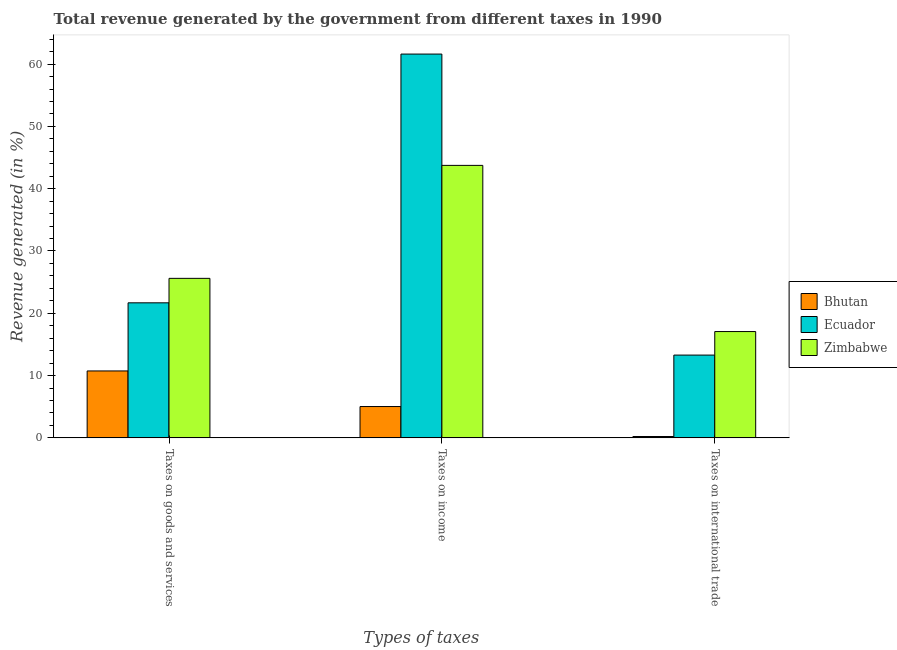Are the number of bars per tick equal to the number of legend labels?
Give a very brief answer. Yes. How many bars are there on the 1st tick from the left?
Provide a succinct answer. 3. What is the label of the 1st group of bars from the left?
Your response must be concise. Taxes on goods and services. What is the percentage of revenue generated by tax on international trade in Bhutan?
Make the answer very short. 0.22. Across all countries, what is the maximum percentage of revenue generated by taxes on income?
Your response must be concise. 61.61. Across all countries, what is the minimum percentage of revenue generated by taxes on goods and services?
Offer a terse response. 10.74. In which country was the percentage of revenue generated by tax on international trade maximum?
Give a very brief answer. Zimbabwe. In which country was the percentage of revenue generated by taxes on goods and services minimum?
Provide a succinct answer. Bhutan. What is the total percentage of revenue generated by taxes on income in the graph?
Give a very brief answer. 110.38. What is the difference between the percentage of revenue generated by taxes on goods and services in Zimbabwe and that in Ecuador?
Your answer should be compact. 3.93. What is the difference between the percentage of revenue generated by taxes on income in Bhutan and the percentage of revenue generated by tax on international trade in Zimbabwe?
Offer a very short reply. -12.04. What is the average percentage of revenue generated by taxes on income per country?
Provide a succinct answer. 36.79. What is the difference between the percentage of revenue generated by taxes on income and percentage of revenue generated by taxes on goods and services in Zimbabwe?
Offer a very short reply. 18.13. What is the ratio of the percentage of revenue generated by taxes on goods and services in Zimbabwe to that in Ecuador?
Provide a succinct answer. 1.18. Is the percentage of revenue generated by tax on international trade in Ecuador less than that in Bhutan?
Offer a terse response. No. Is the difference between the percentage of revenue generated by taxes on goods and services in Zimbabwe and Bhutan greater than the difference between the percentage of revenue generated by taxes on income in Zimbabwe and Bhutan?
Make the answer very short. No. What is the difference between the highest and the second highest percentage of revenue generated by taxes on income?
Your answer should be very brief. 17.87. What is the difference between the highest and the lowest percentage of revenue generated by tax on international trade?
Provide a succinct answer. 16.85. Is the sum of the percentage of revenue generated by taxes on income in Zimbabwe and Bhutan greater than the maximum percentage of revenue generated by tax on international trade across all countries?
Keep it short and to the point. Yes. What does the 3rd bar from the left in Taxes on goods and services represents?
Provide a short and direct response. Zimbabwe. What does the 3rd bar from the right in Taxes on international trade represents?
Make the answer very short. Bhutan. How many bars are there?
Provide a short and direct response. 9. Are all the bars in the graph horizontal?
Your response must be concise. No. What is the difference between two consecutive major ticks on the Y-axis?
Your answer should be very brief. 10. Are the values on the major ticks of Y-axis written in scientific E-notation?
Ensure brevity in your answer.  No. Does the graph contain any zero values?
Provide a succinct answer. No. Where does the legend appear in the graph?
Your answer should be very brief. Center right. How many legend labels are there?
Your answer should be very brief. 3. How are the legend labels stacked?
Your response must be concise. Vertical. What is the title of the graph?
Give a very brief answer. Total revenue generated by the government from different taxes in 1990. What is the label or title of the X-axis?
Make the answer very short. Types of taxes. What is the label or title of the Y-axis?
Give a very brief answer. Revenue generated (in %). What is the Revenue generated (in %) of Bhutan in Taxes on goods and services?
Give a very brief answer. 10.74. What is the Revenue generated (in %) in Ecuador in Taxes on goods and services?
Offer a terse response. 21.68. What is the Revenue generated (in %) of Zimbabwe in Taxes on goods and services?
Make the answer very short. 25.61. What is the Revenue generated (in %) in Bhutan in Taxes on income?
Make the answer very short. 5.03. What is the Revenue generated (in %) of Ecuador in Taxes on income?
Your answer should be compact. 61.61. What is the Revenue generated (in %) of Zimbabwe in Taxes on income?
Your response must be concise. 43.74. What is the Revenue generated (in %) in Bhutan in Taxes on international trade?
Offer a very short reply. 0.22. What is the Revenue generated (in %) of Ecuador in Taxes on international trade?
Keep it short and to the point. 13.29. What is the Revenue generated (in %) of Zimbabwe in Taxes on international trade?
Your answer should be very brief. 17.07. Across all Types of taxes, what is the maximum Revenue generated (in %) in Bhutan?
Provide a short and direct response. 10.74. Across all Types of taxes, what is the maximum Revenue generated (in %) of Ecuador?
Keep it short and to the point. 61.61. Across all Types of taxes, what is the maximum Revenue generated (in %) of Zimbabwe?
Your answer should be very brief. 43.74. Across all Types of taxes, what is the minimum Revenue generated (in %) in Bhutan?
Your response must be concise. 0.22. Across all Types of taxes, what is the minimum Revenue generated (in %) in Ecuador?
Make the answer very short. 13.29. Across all Types of taxes, what is the minimum Revenue generated (in %) of Zimbabwe?
Offer a terse response. 17.07. What is the total Revenue generated (in %) of Bhutan in the graph?
Keep it short and to the point. 15.99. What is the total Revenue generated (in %) in Ecuador in the graph?
Your answer should be compact. 96.58. What is the total Revenue generated (in %) in Zimbabwe in the graph?
Your answer should be very brief. 86.41. What is the difference between the Revenue generated (in %) of Bhutan in Taxes on goods and services and that in Taxes on income?
Give a very brief answer. 5.71. What is the difference between the Revenue generated (in %) in Ecuador in Taxes on goods and services and that in Taxes on income?
Offer a terse response. -39.93. What is the difference between the Revenue generated (in %) in Zimbabwe in Taxes on goods and services and that in Taxes on income?
Your answer should be compact. -18.14. What is the difference between the Revenue generated (in %) of Bhutan in Taxes on goods and services and that in Taxes on international trade?
Give a very brief answer. 10.52. What is the difference between the Revenue generated (in %) in Ecuador in Taxes on goods and services and that in Taxes on international trade?
Your answer should be compact. 8.39. What is the difference between the Revenue generated (in %) in Zimbabwe in Taxes on goods and services and that in Taxes on international trade?
Your answer should be compact. 8.54. What is the difference between the Revenue generated (in %) of Bhutan in Taxes on income and that in Taxes on international trade?
Give a very brief answer. 4.81. What is the difference between the Revenue generated (in %) in Ecuador in Taxes on income and that in Taxes on international trade?
Your answer should be compact. 48.32. What is the difference between the Revenue generated (in %) of Zimbabwe in Taxes on income and that in Taxes on international trade?
Make the answer very short. 26.67. What is the difference between the Revenue generated (in %) of Bhutan in Taxes on goods and services and the Revenue generated (in %) of Ecuador in Taxes on income?
Your response must be concise. -50.87. What is the difference between the Revenue generated (in %) of Bhutan in Taxes on goods and services and the Revenue generated (in %) of Zimbabwe in Taxes on income?
Keep it short and to the point. -33. What is the difference between the Revenue generated (in %) of Ecuador in Taxes on goods and services and the Revenue generated (in %) of Zimbabwe in Taxes on income?
Keep it short and to the point. -22.06. What is the difference between the Revenue generated (in %) in Bhutan in Taxes on goods and services and the Revenue generated (in %) in Ecuador in Taxes on international trade?
Offer a terse response. -2.55. What is the difference between the Revenue generated (in %) in Bhutan in Taxes on goods and services and the Revenue generated (in %) in Zimbabwe in Taxes on international trade?
Provide a short and direct response. -6.32. What is the difference between the Revenue generated (in %) of Ecuador in Taxes on goods and services and the Revenue generated (in %) of Zimbabwe in Taxes on international trade?
Make the answer very short. 4.61. What is the difference between the Revenue generated (in %) in Bhutan in Taxes on income and the Revenue generated (in %) in Ecuador in Taxes on international trade?
Your answer should be compact. -8.26. What is the difference between the Revenue generated (in %) in Bhutan in Taxes on income and the Revenue generated (in %) in Zimbabwe in Taxes on international trade?
Offer a terse response. -12.04. What is the difference between the Revenue generated (in %) in Ecuador in Taxes on income and the Revenue generated (in %) in Zimbabwe in Taxes on international trade?
Your answer should be very brief. 44.54. What is the average Revenue generated (in %) of Bhutan per Types of taxes?
Offer a terse response. 5.33. What is the average Revenue generated (in %) in Ecuador per Types of taxes?
Keep it short and to the point. 32.19. What is the average Revenue generated (in %) in Zimbabwe per Types of taxes?
Make the answer very short. 28.8. What is the difference between the Revenue generated (in %) in Bhutan and Revenue generated (in %) in Ecuador in Taxes on goods and services?
Your answer should be compact. -10.93. What is the difference between the Revenue generated (in %) in Bhutan and Revenue generated (in %) in Zimbabwe in Taxes on goods and services?
Offer a very short reply. -14.86. What is the difference between the Revenue generated (in %) of Ecuador and Revenue generated (in %) of Zimbabwe in Taxes on goods and services?
Your answer should be compact. -3.93. What is the difference between the Revenue generated (in %) in Bhutan and Revenue generated (in %) in Ecuador in Taxes on income?
Provide a short and direct response. -56.58. What is the difference between the Revenue generated (in %) of Bhutan and Revenue generated (in %) of Zimbabwe in Taxes on income?
Give a very brief answer. -38.71. What is the difference between the Revenue generated (in %) of Ecuador and Revenue generated (in %) of Zimbabwe in Taxes on income?
Your answer should be compact. 17.87. What is the difference between the Revenue generated (in %) of Bhutan and Revenue generated (in %) of Ecuador in Taxes on international trade?
Keep it short and to the point. -13.07. What is the difference between the Revenue generated (in %) in Bhutan and Revenue generated (in %) in Zimbabwe in Taxes on international trade?
Your answer should be compact. -16.85. What is the difference between the Revenue generated (in %) in Ecuador and Revenue generated (in %) in Zimbabwe in Taxes on international trade?
Give a very brief answer. -3.78. What is the ratio of the Revenue generated (in %) of Bhutan in Taxes on goods and services to that in Taxes on income?
Make the answer very short. 2.14. What is the ratio of the Revenue generated (in %) of Ecuador in Taxes on goods and services to that in Taxes on income?
Make the answer very short. 0.35. What is the ratio of the Revenue generated (in %) in Zimbabwe in Taxes on goods and services to that in Taxes on income?
Your response must be concise. 0.59. What is the ratio of the Revenue generated (in %) in Bhutan in Taxes on goods and services to that in Taxes on international trade?
Provide a short and direct response. 49.06. What is the ratio of the Revenue generated (in %) of Ecuador in Taxes on goods and services to that in Taxes on international trade?
Your answer should be compact. 1.63. What is the ratio of the Revenue generated (in %) in Zimbabwe in Taxes on goods and services to that in Taxes on international trade?
Make the answer very short. 1.5. What is the ratio of the Revenue generated (in %) of Bhutan in Taxes on income to that in Taxes on international trade?
Your answer should be very brief. 22.97. What is the ratio of the Revenue generated (in %) of Ecuador in Taxes on income to that in Taxes on international trade?
Your answer should be compact. 4.64. What is the ratio of the Revenue generated (in %) in Zimbabwe in Taxes on income to that in Taxes on international trade?
Provide a short and direct response. 2.56. What is the difference between the highest and the second highest Revenue generated (in %) of Bhutan?
Your answer should be compact. 5.71. What is the difference between the highest and the second highest Revenue generated (in %) in Ecuador?
Give a very brief answer. 39.93. What is the difference between the highest and the second highest Revenue generated (in %) in Zimbabwe?
Give a very brief answer. 18.14. What is the difference between the highest and the lowest Revenue generated (in %) of Bhutan?
Give a very brief answer. 10.52. What is the difference between the highest and the lowest Revenue generated (in %) of Ecuador?
Offer a terse response. 48.32. What is the difference between the highest and the lowest Revenue generated (in %) in Zimbabwe?
Provide a short and direct response. 26.67. 